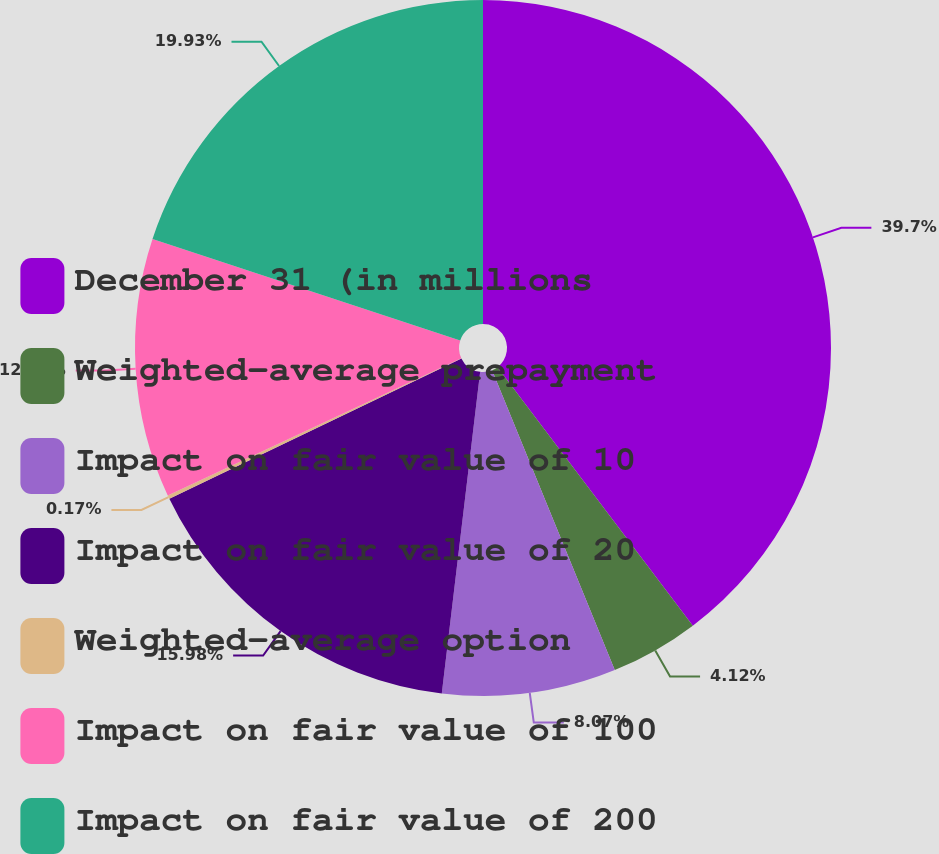Convert chart. <chart><loc_0><loc_0><loc_500><loc_500><pie_chart><fcel>December 31 (in millions<fcel>Weighted-average prepayment<fcel>Impact on fair value of 10<fcel>Impact on fair value of 20<fcel>Weighted-average option<fcel>Impact on fair value of 100<fcel>Impact on fair value of 200<nl><fcel>39.7%<fcel>4.12%<fcel>8.07%<fcel>15.98%<fcel>0.17%<fcel>12.03%<fcel>19.93%<nl></chart> 